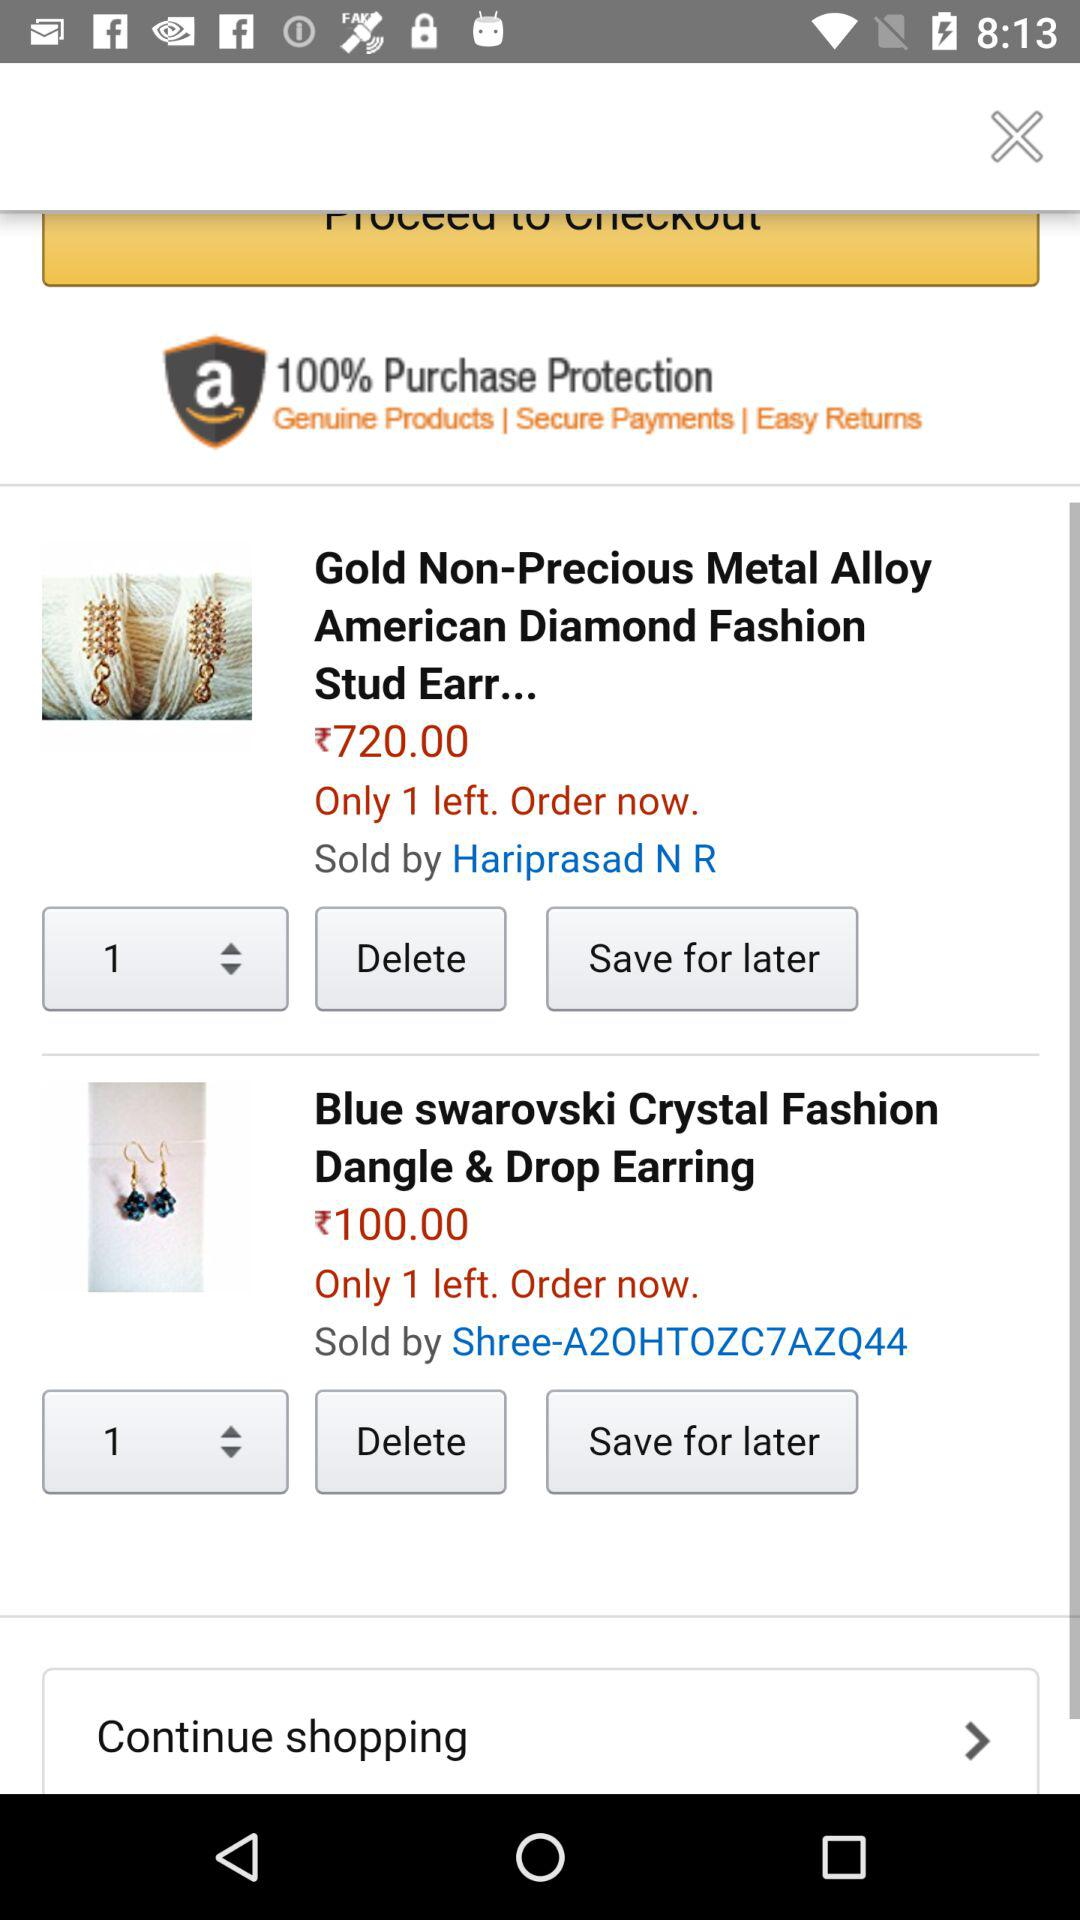How many "Gold Non-Precious Metal Alloy American Diamond Fashion Stud Earr..." are left? There is 1 "Gold Non-Precious Metal Alloy American Diamond Fashion Stud Earr..." left. 